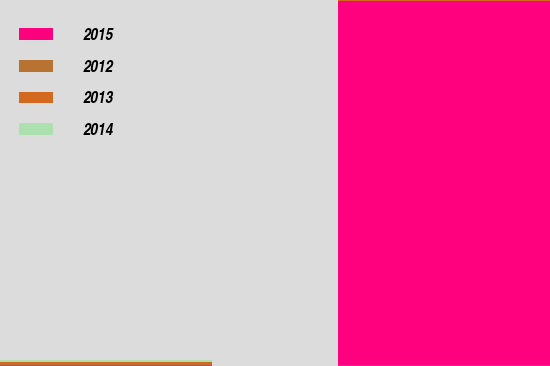Convert chart to OTSL. <chart><loc_0><loc_0><loc_500><loc_500><stacked_bar_chart><ecel><fcel>Vehicles<fcel>Machinery/Equipment<nl><fcel>2015<fcel>21<fcel>5171<nl><fcel>2012<fcel>24<fcel>10<nl><fcel>2013<fcel>23<fcel>8<nl><fcel>2014<fcel>21<fcel>6<nl></chart> 